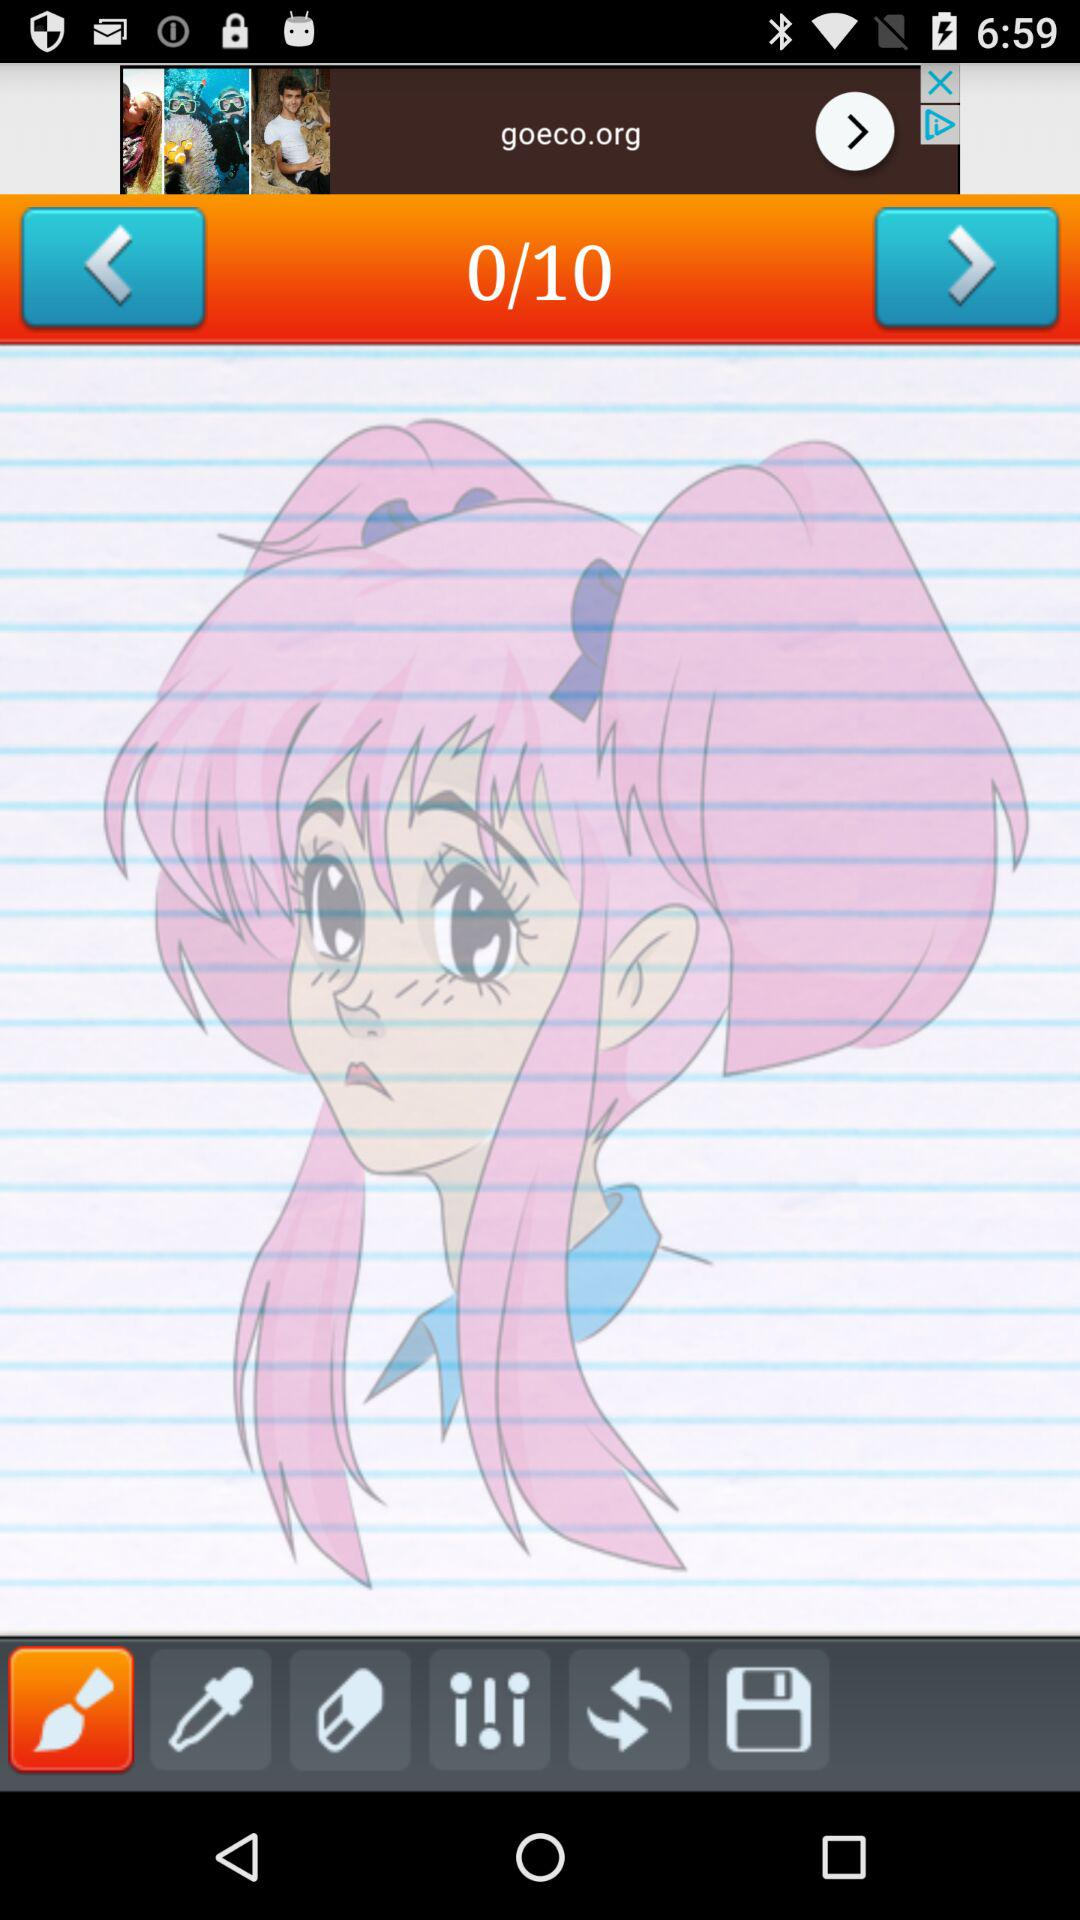How many total pages are there? The total pages are 10. 